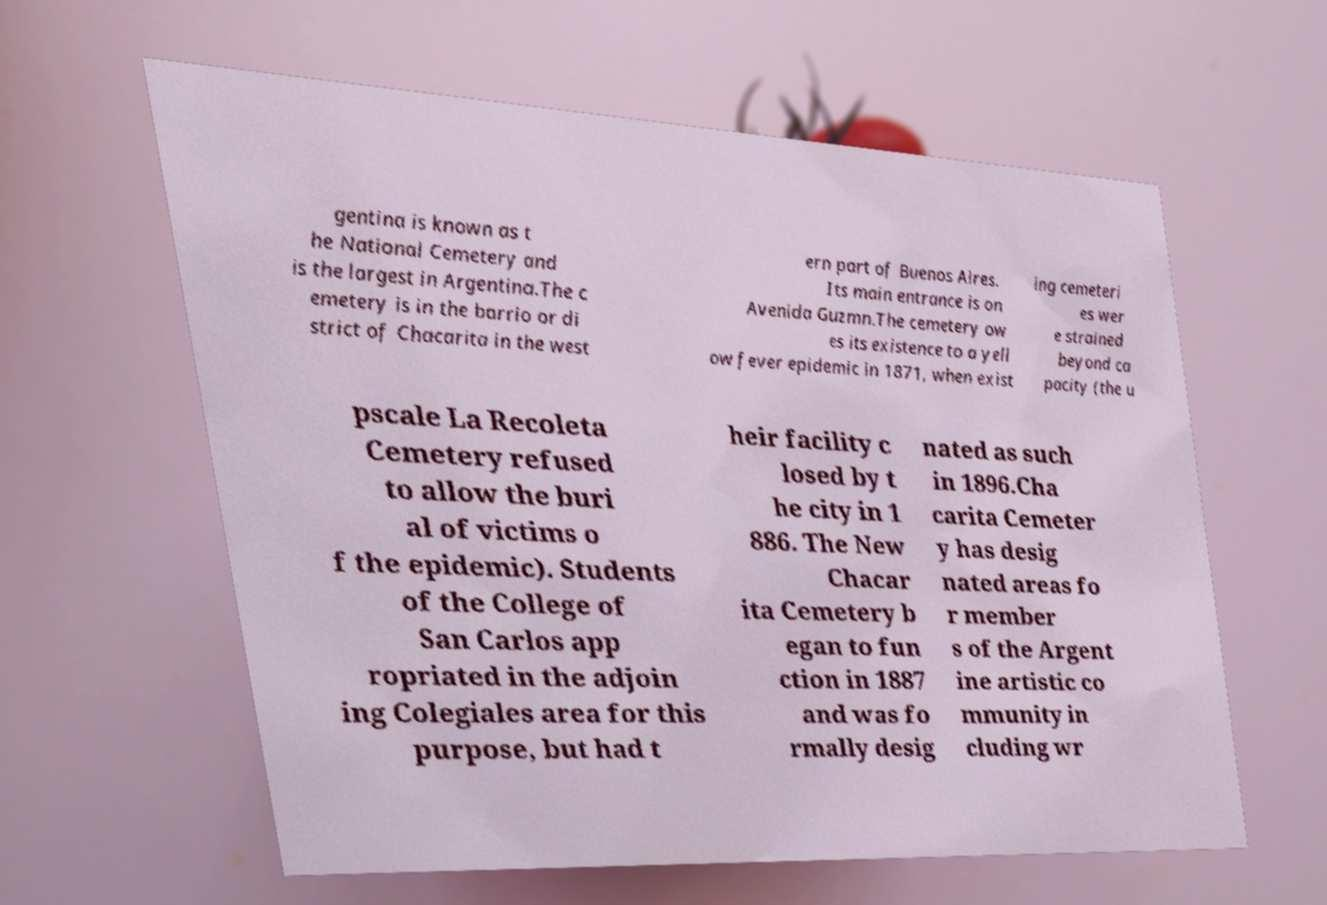I need the written content from this picture converted into text. Can you do that? gentina is known as t he National Cemetery and is the largest in Argentina.The c emetery is in the barrio or di strict of Chacarita in the west ern part of Buenos Aires. Its main entrance is on Avenida Guzmn.The cemetery ow es its existence to a yell ow fever epidemic in 1871, when exist ing cemeteri es wer e strained beyond ca pacity (the u pscale La Recoleta Cemetery refused to allow the buri al of victims o f the epidemic). Students of the College of San Carlos app ropriated in the adjoin ing Colegiales area for this purpose, but had t heir facility c losed by t he city in 1 886. The New Chacar ita Cemetery b egan to fun ction in 1887 and was fo rmally desig nated as such in 1896.Cha carita Cemeter y has desig nated areas fo r member s of the Argent ine artistic co mmunity in cluding wr 